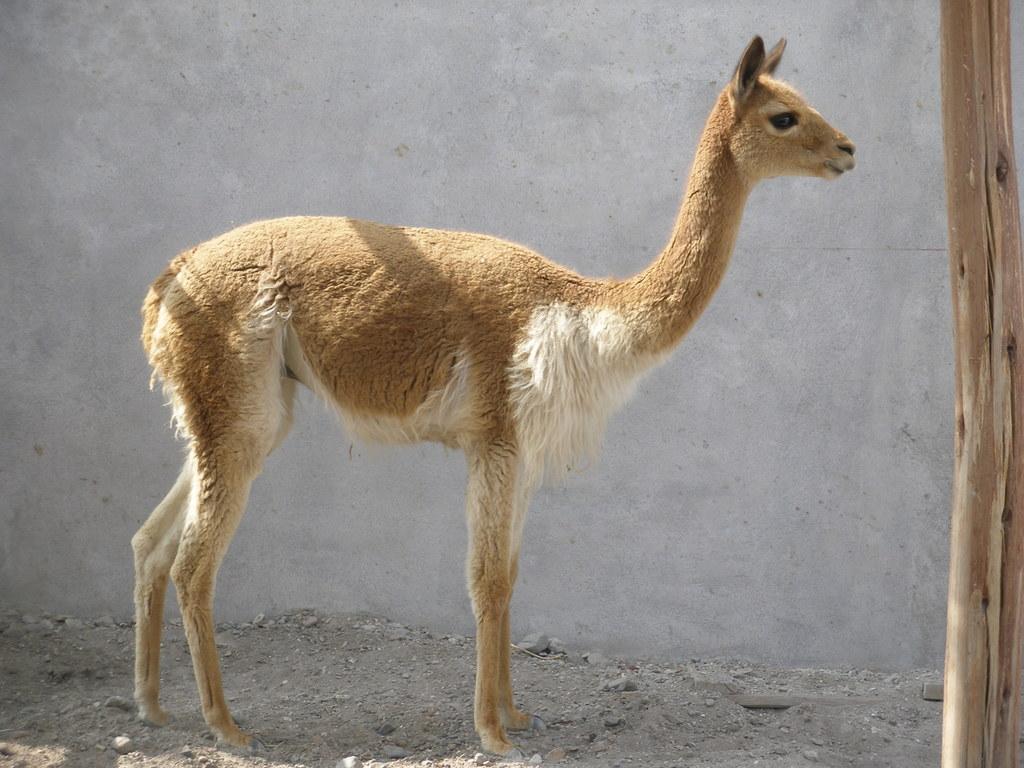Describe this image in one or two sentences. In this picture we see a fawn standing before a cement wall and at the right side of this picture we have a wooden pole. 